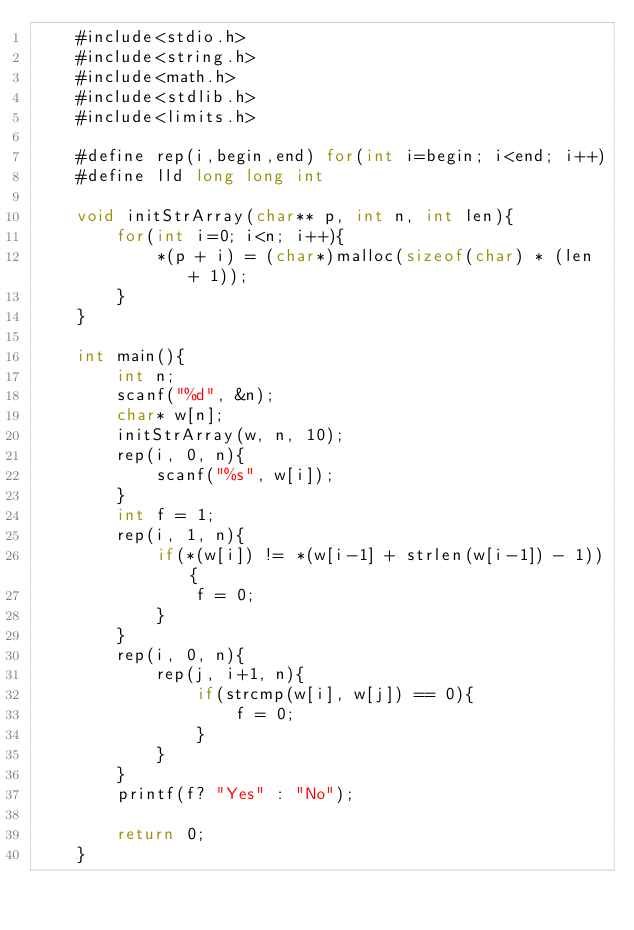Convert code to text. <code><loc_0><loc_0><loc_500><loc_500><_C_>    #include<stdio.h>
    #include<string.h>
    #include<math.h>
    #include<stdlib.h>
    #include<limits.h>
     
    #define rep(i,begin,end) for(int i=begin; i<end; i++)
    #define lld long long int
     
    void initStrArray(char** p, int n, int len){
        for(int i=0; i<n; i++){
            *(p + i) = (char*)malloc(sizeof(char) * (len + 1));
        }
    }
     
    int main(){
        int n;
        scanf("%d", &n);
        char* w[n];
        initStrArray(w, n, 10);
        rep(i, 0, n){
            scanf("%s", w[i]);
        }
        int f = 1;
        rep(i, 1, n){
            if(*(w[i]) != *(w[i-1] + strlen(w[i-1]) - 1)){
                f = 0;
            }
        }
        rep(i, 0, n){
            rep(j, i+1, n){
                if(strcmp(w[i], w[j]) == 0){
                    f = 0;
                }
            }
        }
        printf(f? "Yes" : "No");
     
        return 0;
    }</code> 